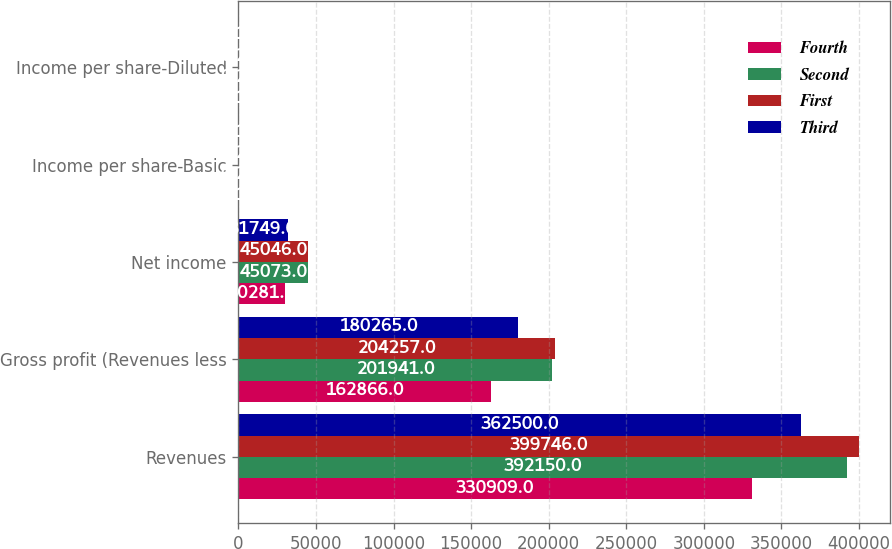<chart> <loc_0><loc_0><loc_500><loc_500><stacked_bar_chart><ecel><fcel>Revenues<fcel>Gross profit (Revenues less<fcel>Net income<fcel>Income per share-Basic<fcel>Income per share-Diluted<nl><fcel>Fourth<fcel>330909<fcel>162866<fcel>30281<fcel>0.14<fcel>0.14<nl><fcel>Second<fcel>392150<fcel>201941<fcel>45073<fcel>0.21<fcel>0.21<nl><fcel>First<fcel>399746<fcel>204257<fcel>45046<fcel>0.21<fcel>0.21<nl><fcel>Third<fcel>362500<fcel>180265<fcel>31749<fcel>0.15<fcel>0.15<nl></chart> 